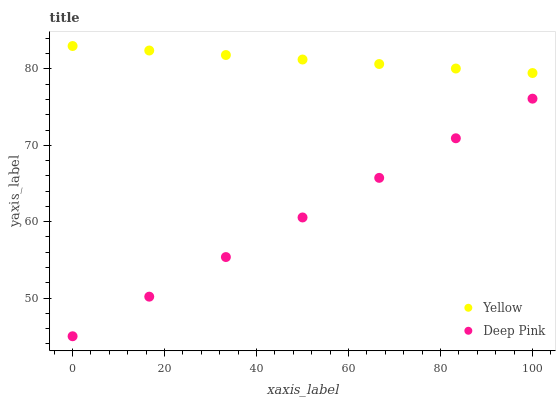Does Deep Pink have the minimum area under the curve?
Answer yes or no. Yes. Does Yellow have the maximum area under the curve?
Answer yes or no. Yes. Does Yellow have the minimum area under the curve?
Answer yes or no. No. Is Deep Pink the smoothest?
Answer yes or no. Yes. Is Yellow the roughest?
Answer yes or no. Yes. Is Yellow the smoothest?
Answer yes or no. No. Does Deep Pink have the lowest value?
Answer yes or no. Yes. Does Yellow have the lowest value?
Answer yes or no. No. Does Yellow have the highest value?
Answer yes or no. Yes. Is Deep Pink less than Yellow?
Answer yes or no. Yes. Is Yellow greater than Deep Pink?
Answer yes or no. Yes. Does Deep Pink intersect Yellow?
Answer yes or no. No. 